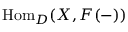Convert formula to latex. <formula><loc_0><loc_0><loc_500><loc_500>{ H o m } _ { D } ( X , F ( - ) )</formula> 